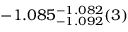<formula> <loc_0><loc_0><loc_500><loc_500>- 1 . 0 8 5 _ { - 1 . 0 9 2 } ^ { - 1 . 0 8 2 } ( 3 )</formula> 